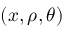Convert formula to latex. <formula><loc_0><loc_0><loc_500><loc_500>( x , \rho , \theta )</formula> 